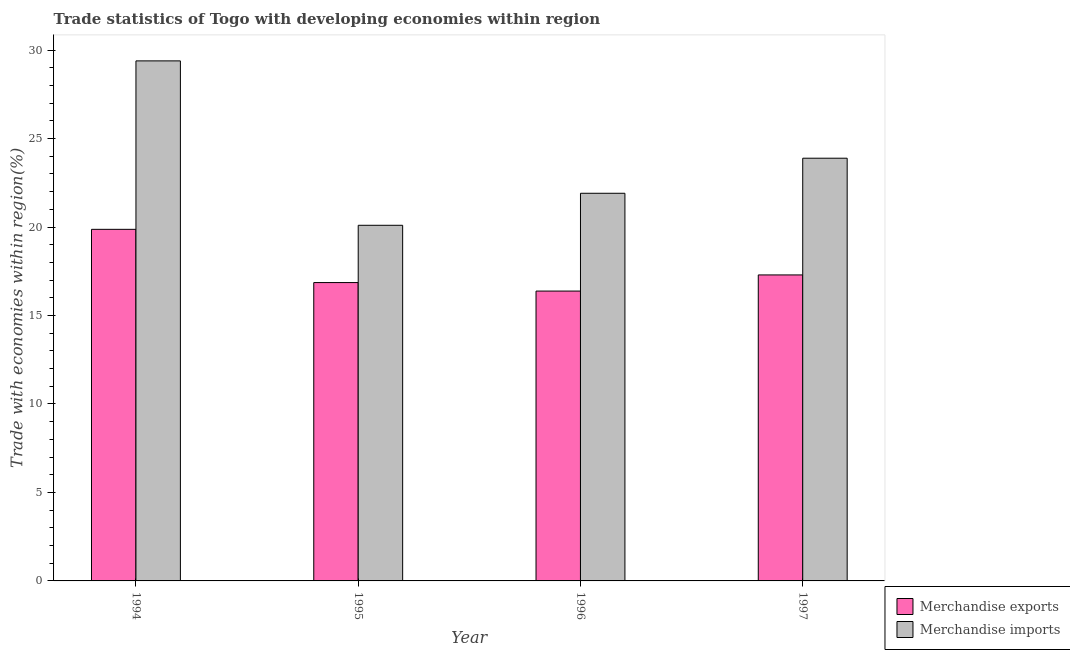Are the number of bars per tick equal to the number of legend labels?
Ensure brevity in your answer.  Yes. Are the number of bars on each tick of the X-axis equal?
Provide a succinct answer. Yes. How many bars are there on the 4th tick from the left?
Provide a short and direct response. 2. What is the label of the 2nd group of bars from the left?
Provide a short and direct response. 1995. What is the merchandise imports in 1997?
Your response must be concise. 23.89. Across all years, what is the maximum merchandise imports?
Offer a terse response. 29.39. Across all years, what is the minimum merchandise exports?
Make the answer very short. 16.38. In which year was the merchandise imports maximum?
Ensure brevity in your answer.  1994. What is the total merchandise imports in the graph?
Keep it short and to the point. 95.29. What is the difference between the merchandise imports in 1994 and that in 1995?
Your response must be concise. 9.29. What is the difference between the merchandise imports in 1997 and the merchandise exports in 1995?
Your response must be concise. 3.79. What is the average merchandise exports per year?
Ensure brevity in your answer.  17.6. What is the ratio of the merchandise exports in 1994 to that in 1995?
Your response must be concise. 1.18. Is the merchandise imports in 1995 less than that in 1997?
Make the answer very short. Yes. Is the difference between the merchandise imports in 1996 and 1997 greater than the difference between the merchandise exports in 1996 and 1997?
Your answer should be compact. No. What is the difference between the highest and the second highest merchandise exports?
Offer a terse response. 2.58. What is the difference between the highest and the lowest merchandise imports?
Offer a terse response. 9.29. Is the sum of the merchandise imports in 1994 and 1997 greater than the maximum merchandise exports across all years?
Your answer should be compact. Yes. How many years are there in the graph?
Give a very brief answer. 4. Are the values on the major ticks of Y-axis written in scientific E-notation?
Make the answer very short. No. Where does the legend appear in the graph?
Ensure brevity in your answer.  Bottom right. How many legend labels are there?
Provide a short and direct response. 2. How are the legend labels stacked?
Give a very brief answer. Vertical. What is the title of the graph?
Provide a succinct answer. Trade statistics of Togo with developing economies within region. What is the label or title of the Y-axis?
Your response must be concise. Trade with economies within region(%). What is the Trade with economies within region(%) of Merchandise exports in 1994?
Provide a short and direct response. 19.87. What is the Trade with economies within region(%) in Merchandise imports in 1994?
Give a very brief answer. 29.39. What is the Trade with economies within region(%) in Merchandise exports in 1995?
Ensure brevity in your answer.  16.86. What is the Trade with economies within region(%) in Merchandise imports in 1995?
Provide a succinct answer. 20.1. What is the Trade with economies within region(%) of Merchandise exports in 1996?
Offer a very short reply. 16.38. What is the Trade with economies within region(%) of Merchandise imports in 1996?
Your answer should be compact. 21.91. What is the Trade with economies within region(%) in Merchandise exports in 1997?
Provide a short and direct response. 17.29. What is the Trade with economies within region(%) in Merchandise imports in 1997?
Provide a short and direct response. 23.89. Across all years, what is the maximum Trade with economies within region(%) of Merchandise exports?
Provide a succinct answer. 19.87. Across all years, what is the maximum Trade with economies within region(%) of Merchandise imports?
Your answer should be very brief. 29.39. Across all years, what is the minimum Trade with economies within region(%) of Merchandise exports?
Keep it short and to the point. 16.38. Across all years, what is the minimum Trade with economies within region(%) of Merchandise imports?
Keep it short and to the point. 20.1. What is the total Trade with economies within region(%) of Merchandise exports in the graph?
Give a very brief answer. 70.41. What is the total Trade with economies within region(%) in Merchandise imports in the graph?
Ensure brevity in your answer.  95.29. What is the difference between the Trade with economies within region(%) of Merchandise exports in 1994 and that in 1995?
Provide a succinct answer. 3.01. What is the difference between the Trade with economies within region(%) in Merchandise imports in 1994 and that in 1995?
Ensure brevity in your answer.  9.29. What is the difference between the Trade with economies within region(%) of Merchandise exports in 1994 and that in 1996?
Provide a short and direct response. 3.49. What is the difference between the Trade with economies within region(%) of Merchandise imports in 1994 and that in 1996?
Ensure brevity in your answer.  7.48. What is the difference between the Trade with economies within region(%) in Merchandise exports in 1994 and that in 1997?
Ensure brevity in your answer.  2.58. What is the difference between the Trade with economies within region(%) in Merchandise imports in 1994 and that in 1997?
Your answer should be compact. 5.5. What is the difference between the Trade with economies within region(%) in Merchandise exports in 1995 and that in 1996?
Offer a very short reply. 0.48. What is the difference between the Trade with economies within region(%) of Merchandise imports in 1995 and that in 1996?
Make the answer very short. -1.81. What is the difference between the Trade with economies within region(%) in Merchandise exports in 1995 and that in 1997?
Ensure brevity in your answer.  -0.43. What is the difference between the Trade with economies within region(%) in Merchandise imports in 1995 and that in 1997?
Your answer should be compact. -3.79. What is the difference between the Trade with economies within region(%) of Merchandise exports in 1996 and that in 1997?
Your answer should be compact. -0.91. What is the difference between the Trade with economies within region(%) in Merchandise imports in 1996 and that in 1997?
Provide a short and direct response. -1.98. What is the difference between the Trade with economies within region(%) in Merchandise exports in 1994 and the Trade with economies within region(%) in Merchandise imports in 1995?
Provide a short and direct response. -0.23. What is the difference between the Trade with economies within region(%) of Merchandise exports in 1994 and the Trade with economies within region(%) of Merchandise imports in 1996?
Offer a terse response. -2.04. What is the difference between the Trade with economies within region(%) of Merchandise exports in 1994 and the Trade with economies within region(%) of Merchandise imports in 1997?
Make the answer very short. -4.02. What is the difference between the Trade with economies within region(%) in Merchandise exports in 1995 and the Trade with economies within region(%) in Merchandise imports in 1996?
Provide a short and direct response. -5.05. What is the difference between the Trade with economies within region(%) of Merchandise exports in 1995 and the Trade with economies within region(%) of Merchandise imports in 1997?
Provide a short and direct response. -7.03. What is the difference between the Trade with economies within region(%) in Merchandise exports in 1996 and the Trade with economies within region(%) in Merchandise imports in 1997?
Make the answer very short. -7.51. What is the average Trade with economies within region(%) in Merchandise exports per year?
Ensure brevity in your answer.  17.6. What is the average Trade with economies within region(%) in Merchandise imports per year?
Give a very brief answer. 23.82. In the year 1994, what is the difference between the Trade with economies within region(%) in Merchandise exports and Trade with economies within region(%) in Merchandise imports?
Provide a succinct answer. -9.52. In the year 1995, what is the difference between the Trade with economies within region(%) of Merchandise exports and Trade with economies within region(%) of Merchandise imports?
Your answer should be compact. -3.24. In the year 1996, what is the difference between the Trade with economies within region(%) in Merchandise exports and Trade with economies within region(%) in Merchandise imports?
Ensure brevity in your answer.  -5.53. In the year 1997, what is the difference between the Trade with economies within region(%) in Merchandise exports and Trade with economies within region(%) in Merchandise imports?
Your answer should be very brief. -6.6. What is the ratio of the Trade with economies within region(%) in Merchandise exports in 1994 to that in 1995?
Make the answer very short. 1.18. What is the ratio of the Trade with economies within region(%) of Merchandise imports in 1994 to that in 1995?
Your answer should be very brief. 1.46. What is the ratio of the Trade with economies within region(%) in Merchandise exports in 1994 to that in 1996?
Your response must be concise. 1.21. What is the ratio of the Trade with economies within region(%) of Merchandise imports in 1994 to that in 1996?
Make the answer very short. 1.34. What is the ratio of the Trade with economies within region(%) of Merchandise exports in 1994 to that in 1997?
Offer a terse response. 1.15. What is the ratio of the Trade with economies within region(%) in Merchandise imports in 1994 to that in 1997?
Offer a very short reply. 1.23. What is the ratio of the Trade with economies within region(%) in Merchandise exports in 1995 to that in 1996?
Keep it short and to the point. 1.03. What is the ratio of the Trade with economies within region(%) of Merchandise imports in 1995 to that in 1996?
Provide a short and direct response. 0.92. What is the ratio of the Trade with economies within region(%) of Merchandise imports in 1995 to that in 1997?
Provide a short and direct response. 0.84. What is the ratio of the Trade with economies within region(%) of Merchandise exports in 1996 to that in 1997?
Provide a succinct answer. 0.95. What is the ratio of the Trade with economies within region(%) of Merchandise imports in 1996 to that in 1997?
Your response must be concise. 0.92. What is the difference between the highest and the second highest Trade with economies within region(%) in Merchandise exports?
Your answer should be very brief. 2.58. What is the difference between the highest and the second highest Trade with economies within region(%) of Merchandise imports?
Your answer should be very brief. 5.5. What is the difference between the highest and the lowest Trade with economies within region(%) in Merchandise exports?
Your answer should be very brief. 3.49. What is the difference between the highest and the lowest Trade with economies within region(%) in Merchandise imports?
Keep it short and to the point. 9.29. 